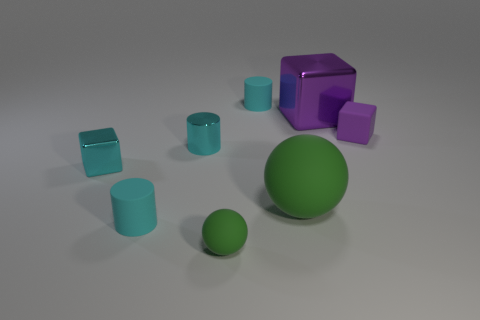Can you tell if this scene is physically real or digitally created? The scene appears to be digitally rendered. Clues such as the perfectly smooth surfaces, uniform coloring, and the overall cleanliness of the setting suggest that this is a computer-generated image designed to mimic a real-life setup. 